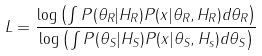<formula> <loc_0><loc_0><loc_500><loc_500>L = \frac { \log \left ( \int P ( \theta _ { R } | H _ { R } ) P ( x | \theta _ { R } , H _ { R } ) d \theta _ { R } \right ) } { \log \left ( \int P ( \theta _ { S } | H _ { S } ) P ( x | \theta _ { S } , H _ { s } ) d \theta _ { S } \right ) }</formula> 